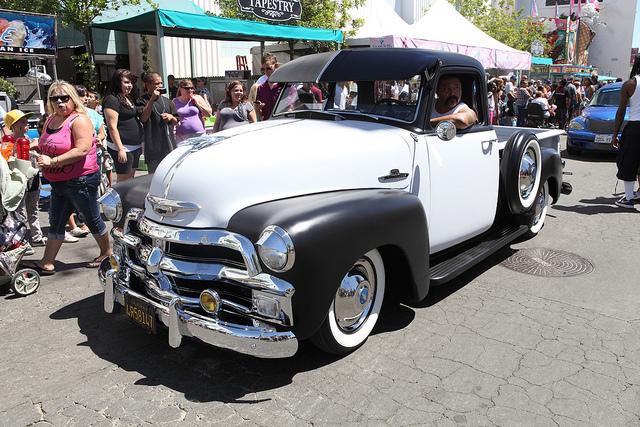Is this car a recent model?
Quick response, please. No. What color is the hood of the truck?
Give a very brief answer. White. How many tires does this vehicle have?
Quick response, please. 5. Is a man driving?
Write a very short answer. Yes. What is the make of the truck?
Quick response, please. Ford. 